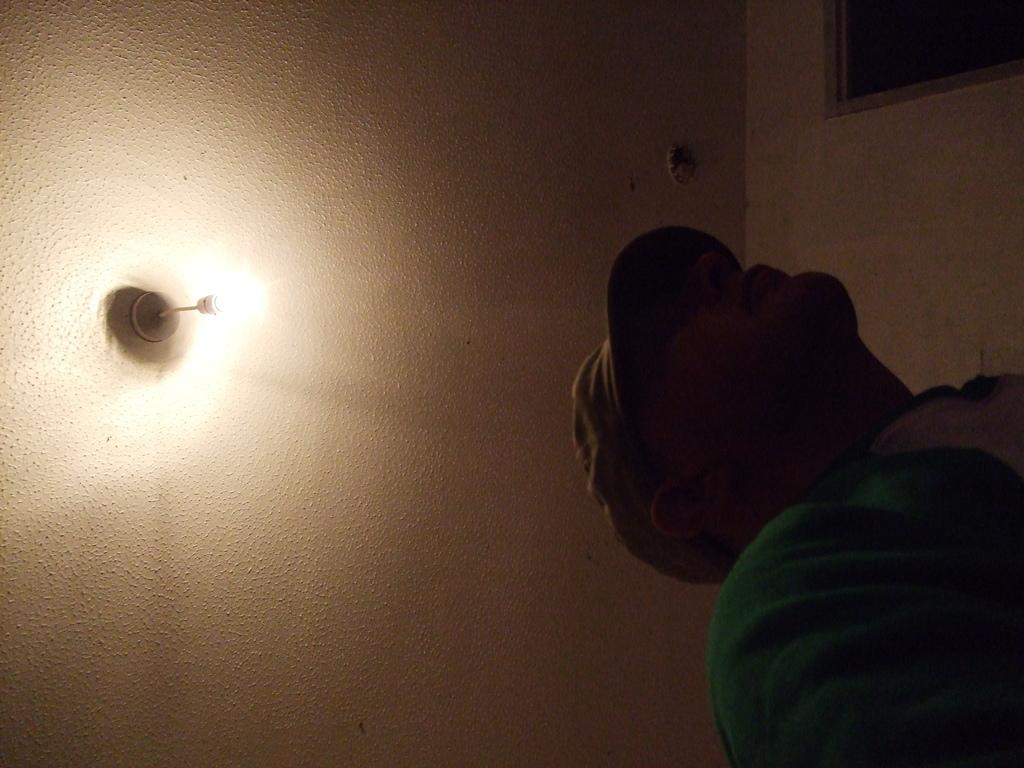What is the main subject of the image? There is a person standing in the image. Can you describe the person's attire? The person is wearing a cap. What can be seen above the person in the image? There is a ceiling visible in the image. What is attached to the ceiling? A light is present on the ceiling. What type of advice is the person giving in the image? There is no indication in the image that the person is giving advice, as the image only shows the person standing and wearing a cap. 